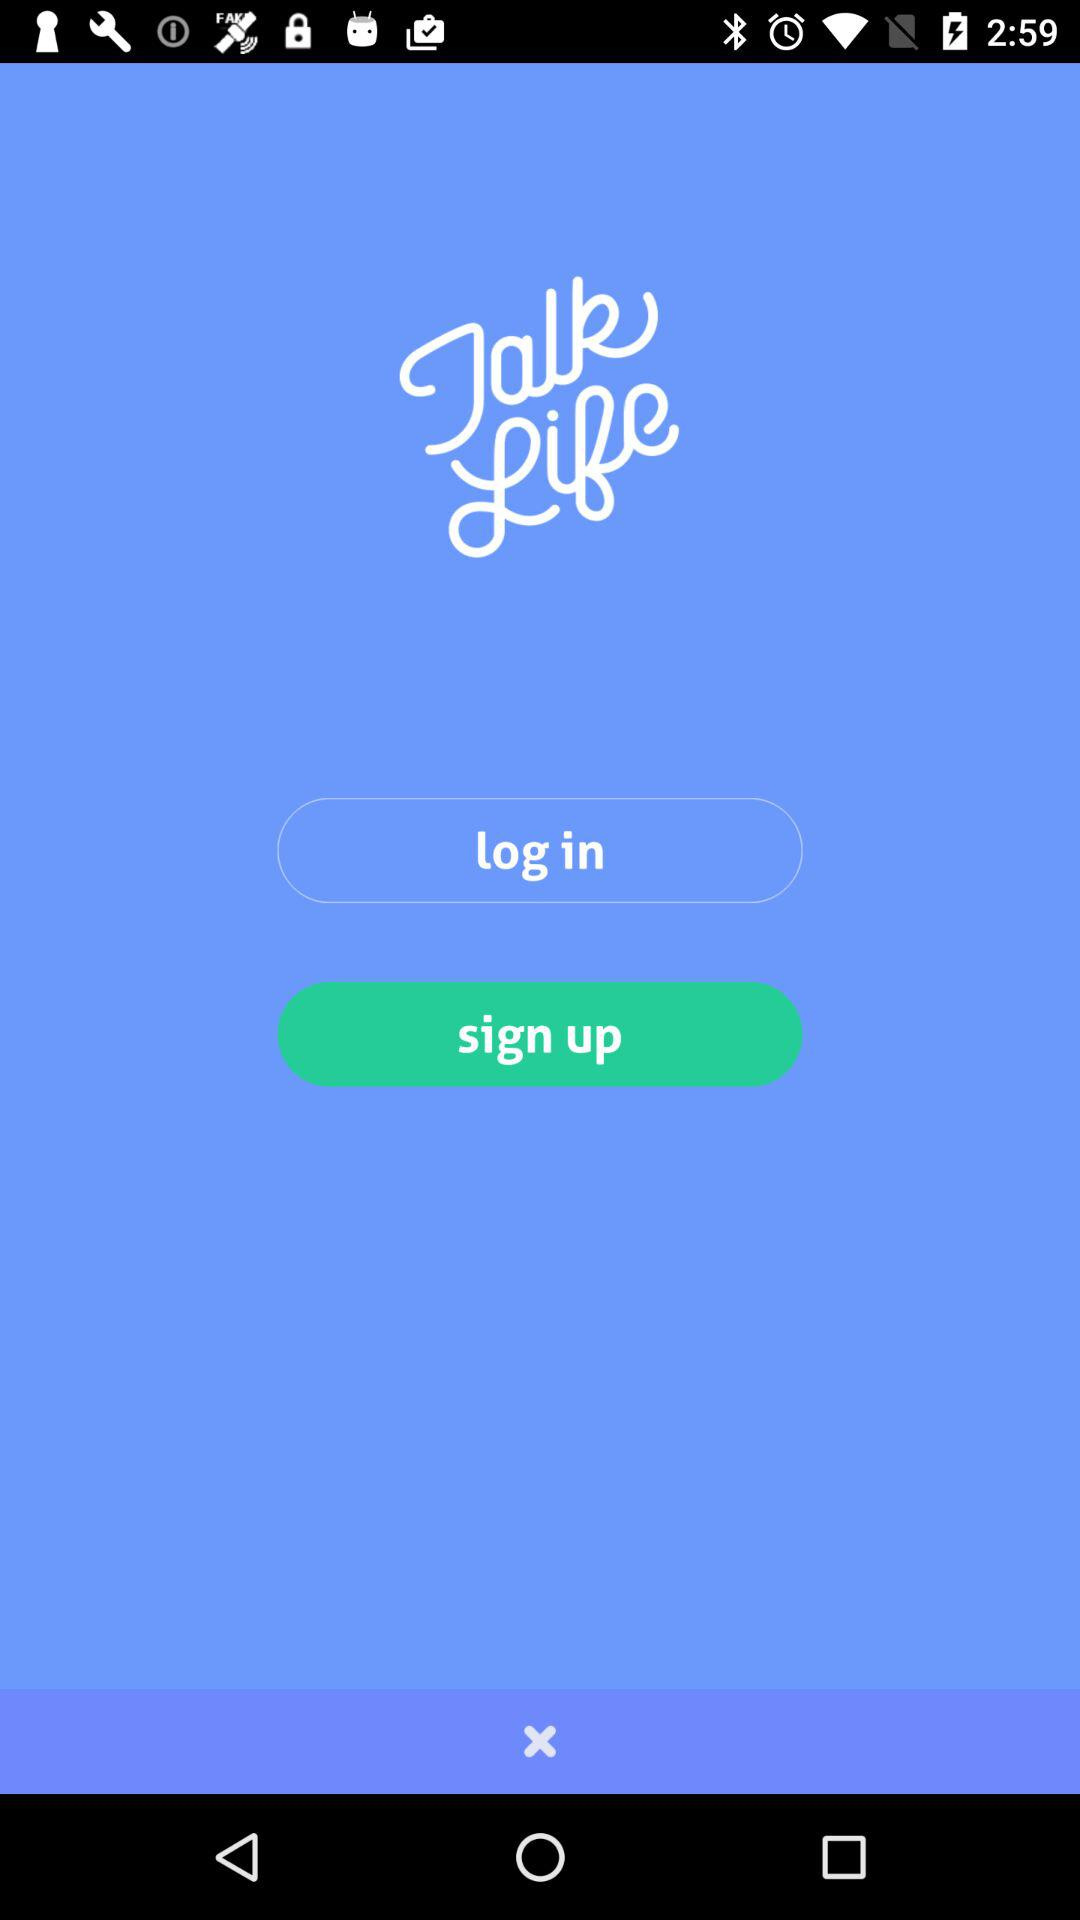Who is this application powered by?
When the provided information is insufficient, respond with <no answer>. <no answer> 